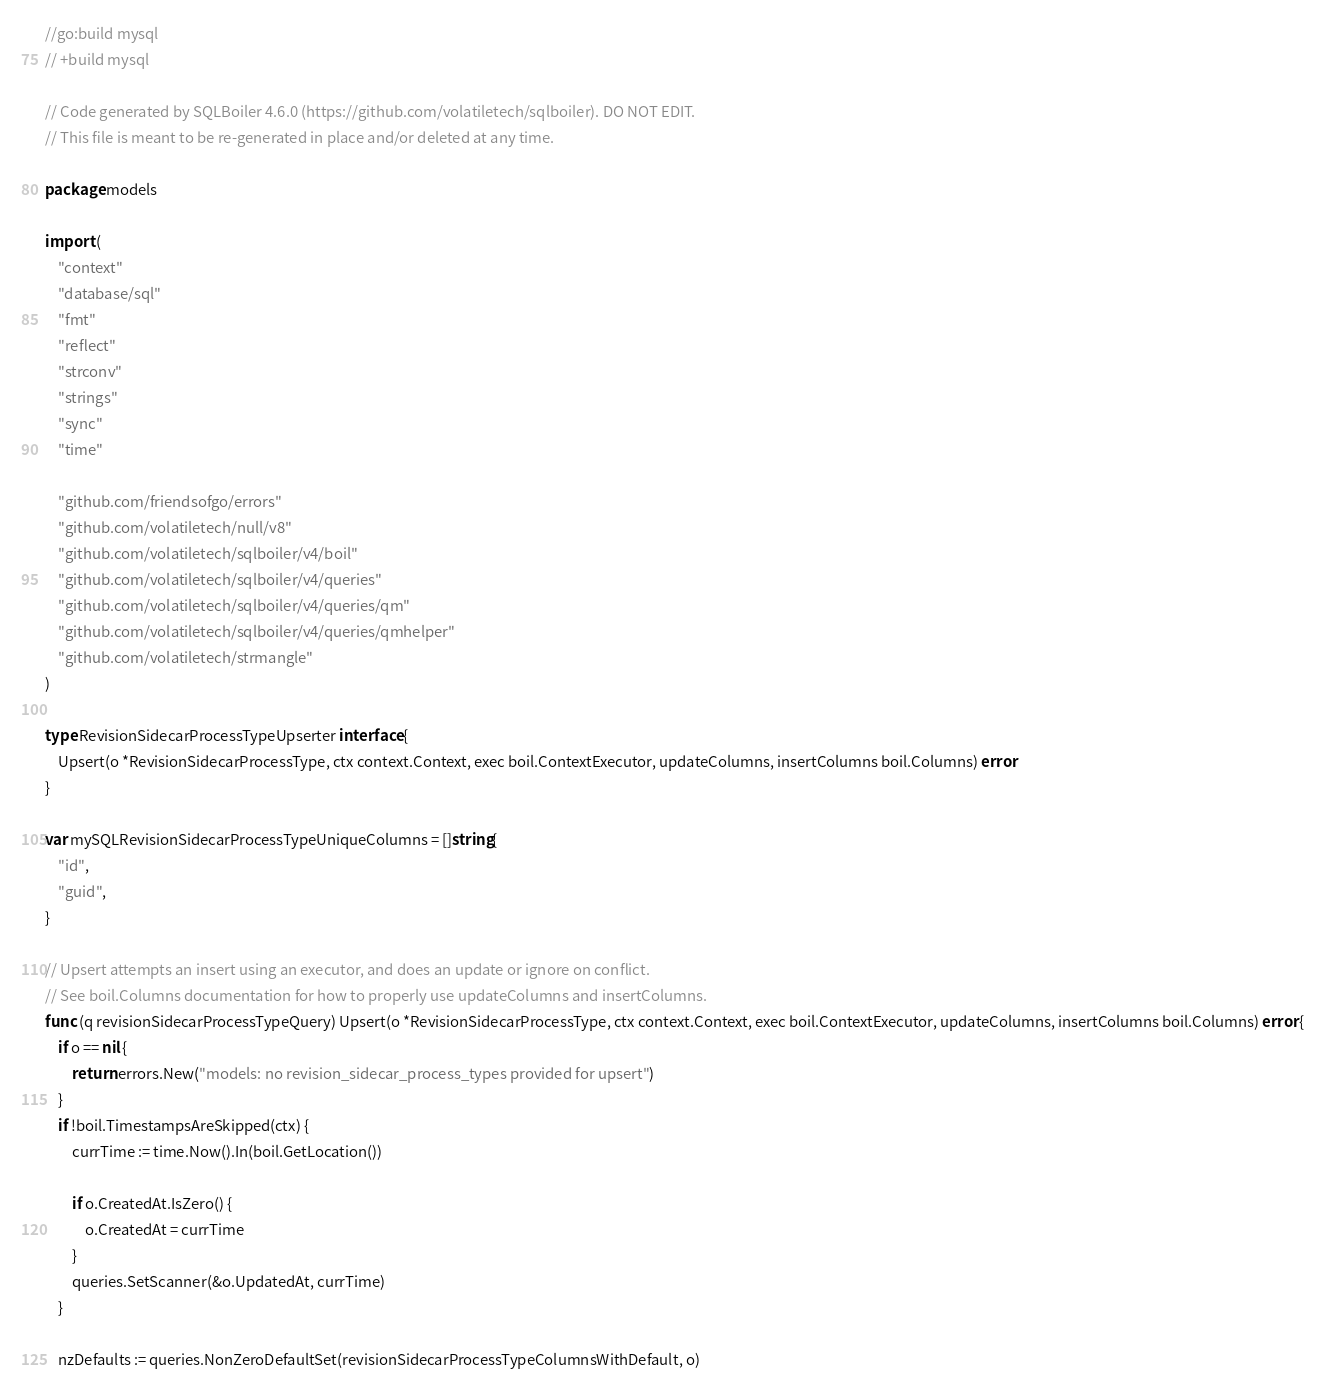Convert code to text. <code><loc_0><loc_0><loc_500><loc_500><_Go_>//go:build mysql
// +build mysql

// Code generated by SQLBoiler 4.6.0 (https://github.com/volatiletech/sqlboiler). DO NOT EDIT.
// This file is meant to be re-generated in place and/or deleted at any time.

package models

import (
	"context"
	"database/sql"
	"fmt"
	"reflect"
	"strconv"
	"strings"
	"sync"
	"time"

	"github.com/friendsofgo/errors"
	"github.com/volatiletech/null/v8"
	"github.com/volatiletech/sqlboiler/v4/boil"
	"github.com/volatiletech/sqlboiler/v4/queries"
	"github.com/volatiletech/sqlboiler/v4/queries/qm"
	"github.com/volatiletech/sqlboiler/v4/queries/qmhelper"
	"github.com/volatiletech/strmangle"
)

type RevisionSidecarProcessTypeUpserter interface {
	Upsert(o *RevisionSidecarProcessType, ctx context.Context, exec boil.ContextExecutor, updateColumns, insertColumns boil.Columns) error
}

var mySQLRevisionSidecarProcessTypeUniqueColumns = []string{
	"id",
	"guid",
}

// Upsert attempts an insert using an executor, and does an update or ignore on conflict.
// See boil.Columns documentation for how to properly use updateColumns and insertColumns.
func (q revisionSidecarProcessTypeQuery) Upsert(o *RevisionSidecarProcessType, ctx context.Context, exec boil.ContextExecutor, updateColumns, insertColumns boil.Columns) error {
	if o == nil {
		return errors.New("models: no revision_sidecar_process_types provided for upsert")
	}
	if !boil.TimestampsAreSkipped(ctx) {
		currTime := time.Now().In(boil.GetLocation())

		if o.CreatedAt.IsZero() {
			o.CreatedAt = currTime
		}
		queries.SetScanner(&o.UpdatedAt, currTime)
	}

	nzDefaults := queries.NonZeroDefaultSet(revisionSidecarProcessTypeColumnsWithDefault, o)</code> 